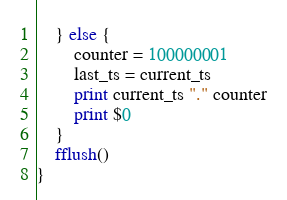Convert code to text. <code><loc_0><loc_0><loc_500><loc_500><_Awk_>	} else {
		counter = 100000001
		last_ts = current_ts
		print current_ts "." counter
		print $0
	}
	fflush()
}
</code> 